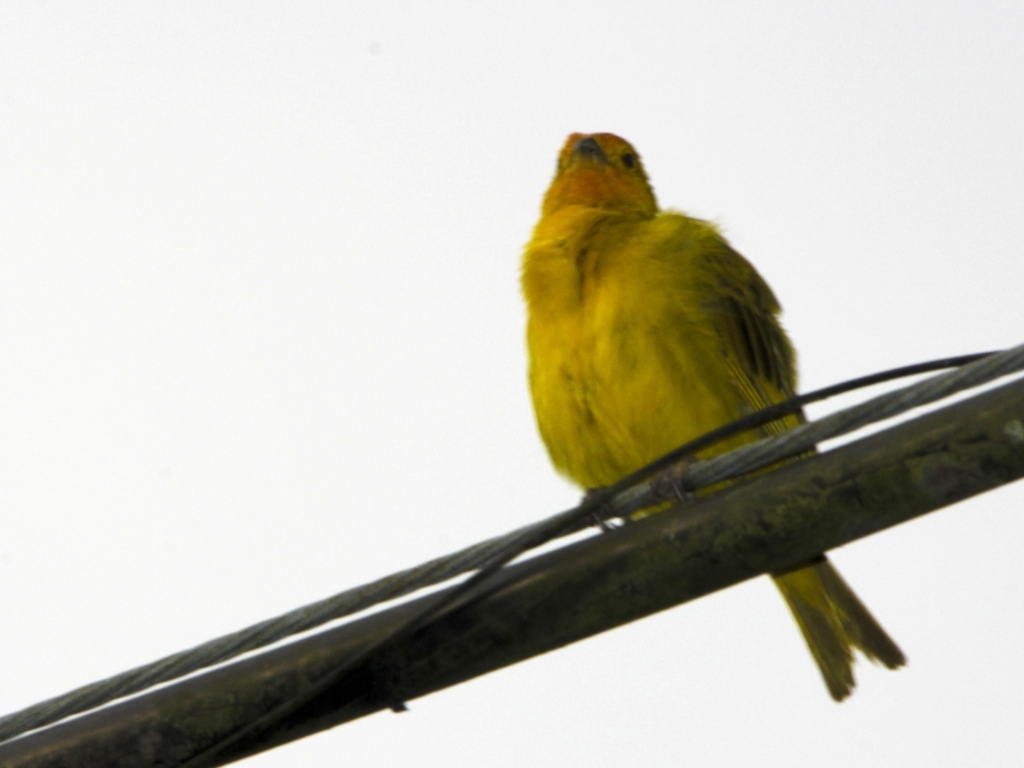Can you tell me about the environmental conditions that this image suggests? The muted and overcast background suggests a dreary day, likely with overcast weather, which in turn could imply it was taken during cooler weather or a transitional season. The bird's fluffed feathers also suggest it may be trying to retain warmth. 